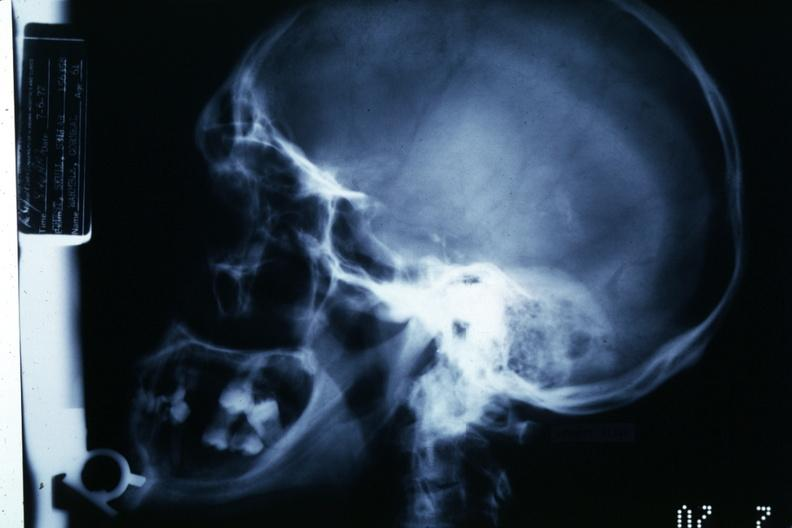s chromophobe adenoma present?
Answer the question using a single word or phrase. Yes 